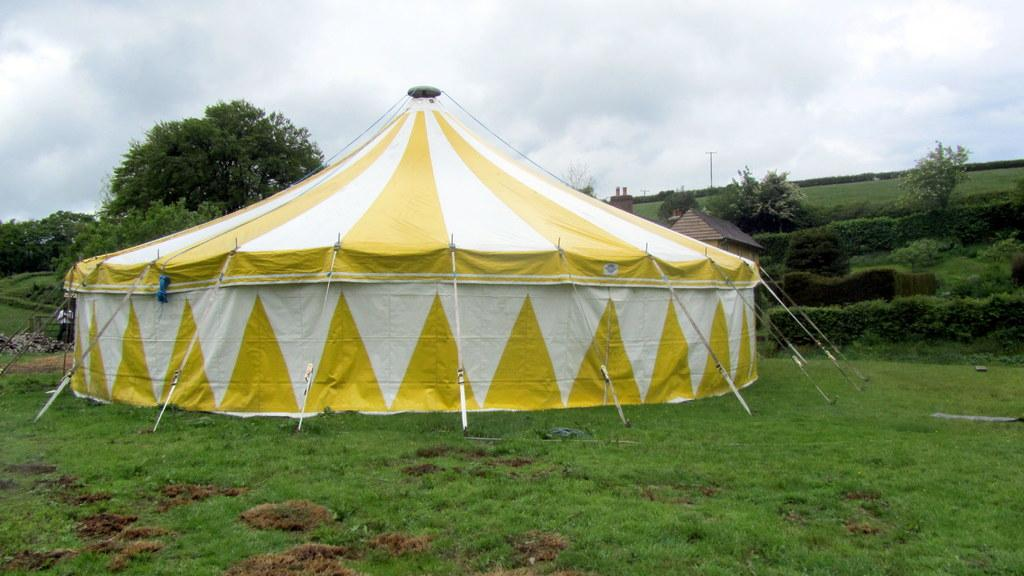What type of shelter is present in the image? There is a tent in the image. What type of natural environment is visible in the image? Trees, stones, grass, plants, and the sky are visible in the image. What type of structure is also present in the image? There is a house in the image. Who or what is visible in the image? A person is visible in the image. What is visible in the background of the image? The sky is visible in the background of the image, with clouds present. What type of sugar is being used to sweeten the crib in the image? There is no sugar or crib present in the image. How does the sponge absorb the water in the image? There is no sponge present in the image. 